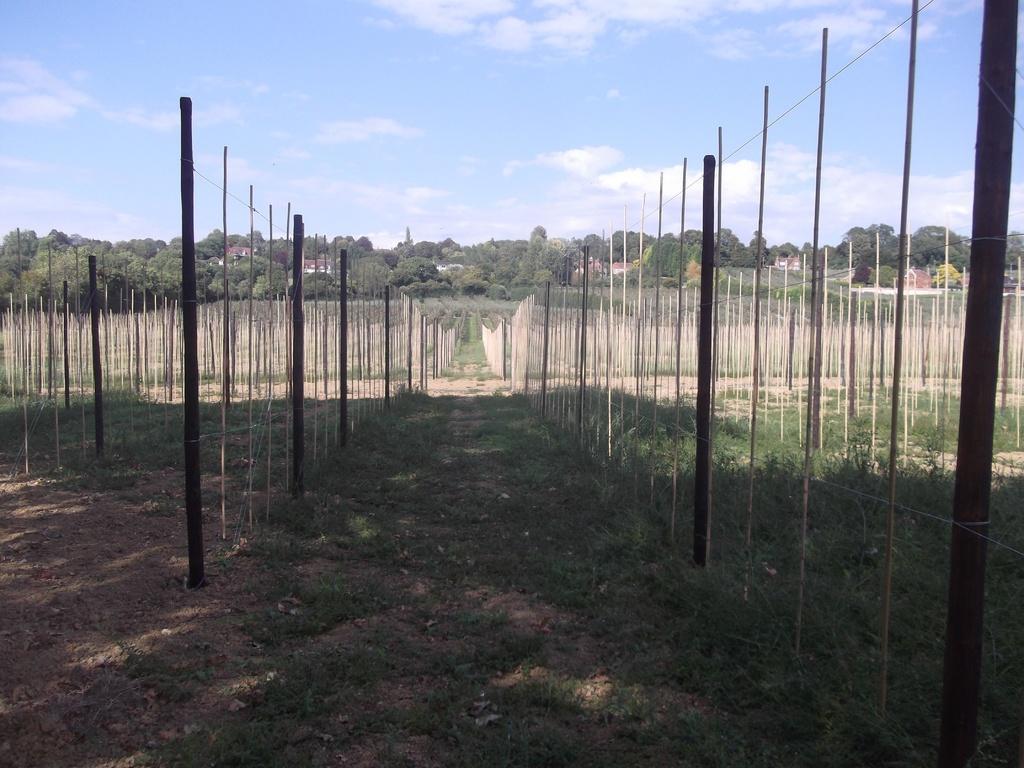Could you give a brief overview of what you see in this image? In this image we can see a group of poles, group of trees and buildings. In the background, we can see the cloudy sky. 